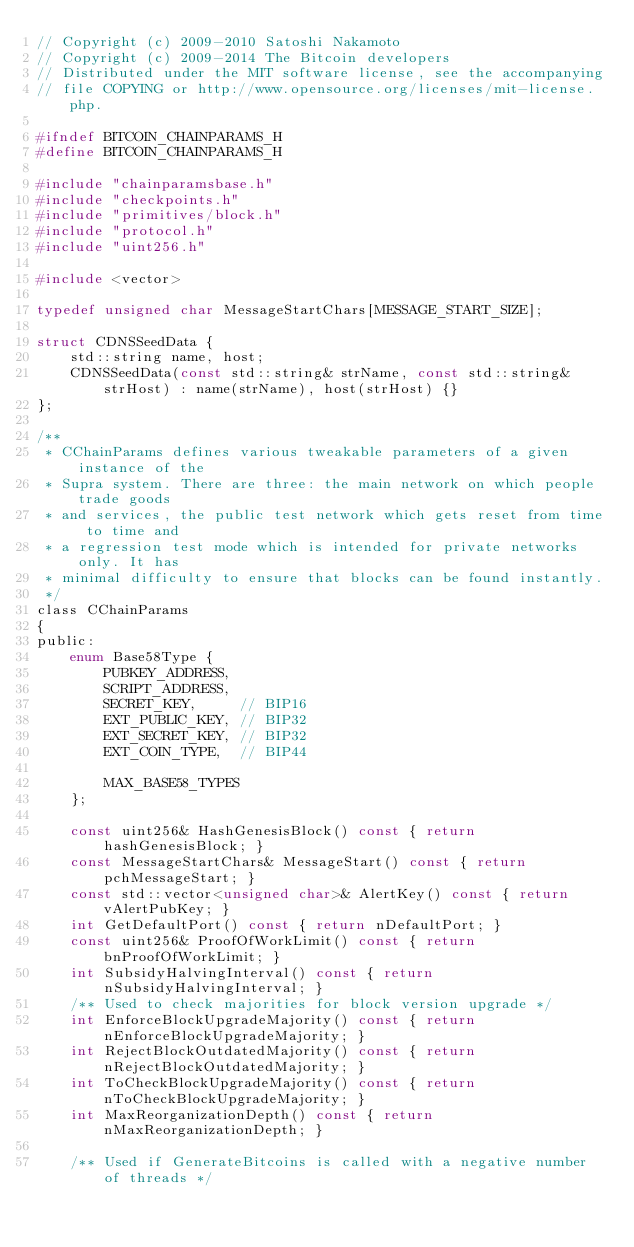Convert code to text. <code><loc_0><loc_0><loc_500><loc_500><_C_>// Copyright (c) 2009-2010 Satoshi Nakamoto
// Copyright (c) 2009-2014 The Bitcoin developers
// Distributed under the MIT software license, see the accompanying
// file COPYING or http://www.opensource.org/licenses/mit-license.php.

#ifndef BITCOIN_CHAINPARAMS_H
#define BITCOIN_CHAINPARAMS_H

#include "chainparamsbase.h"
#include "checkpoints.h"
#include "primitives/block.h"
#include "protocol.h"
#include "uint256.h"

#include <vector>

typedef unsigned char MessageStartChars[MESSAGE_START_SIZE];

struct CDNSSeedData {
    std::string name, host;
    CDNSSeedData(const std::string& strName, const std::string& strHost) : name(strName), host(strHost) {}
};

/**
 * CChainParams defines various tweakable parameters of a given instance of the
 * Supra system. There are three: the main network on which people trade goods
 * and services, the public test network which gets reset from time to time and
 * a regression test mode which is intended for private networks only. It has
 * minimal difficulty to ensure that blocks can be found instantly.
 */
class CChainParams
{
public:
    enum Base58Type {
        PUBKEY_ADDRESS,
        SCRIPT_ADDRESS,
        SECRET_KEY,     // BIP16
        EXT_PUBLIC_KEY, // BIP32
        EXT_SECRET_KEY, // BIP32
        EXT_COIN_TYPE,  // BIP44

        MAX_BASE58_TYPES
    };

    const uint256& HashGenesisBlock() const { return hashGenesisBlock; }
    const MessageStartChars& MessageStart() const { return pchMessageStart; }
    const std::vector<unsigned char>& AlertKey() const { return vAlertPubKey; }
    int GetDefaultPort() const { return nDefaultPort; }
    const uint256& ProofOfWorkLimit() const { return bnProofOfWorkLimit; }
    int SubsidyHalvingInterval() const { return nSubsidyHalvingInterval; }
    /** Used to check majorities for block version upgrade */
    int EnforceBlockUpgradeMajority() const { return nEnforceBlockUpgradeMajority; }
    int RejectBlockOutdatedMajority() const { return nRejectBlockOutdatedMajority; }
    int ToCheckBlockUpgradeMajority() const { return nToCheckBlockUpgradeMajority; }
    int MaxReorganizationDepth() const { return nMaxReorganizationDepth; }

    /** Used if GenerateBitcoins is called with a negative number of threads */</code> 